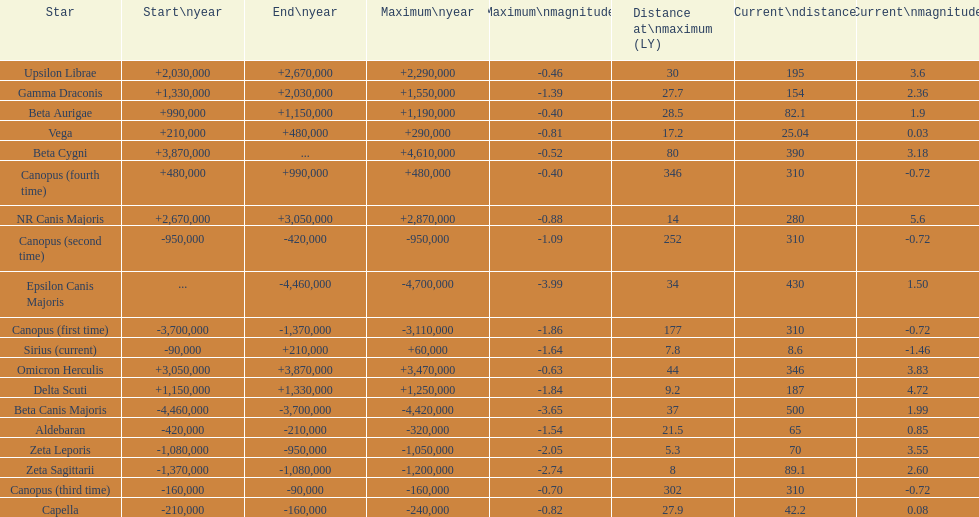What is the only star with a distance at maximum of 80? Beta Cygni. 